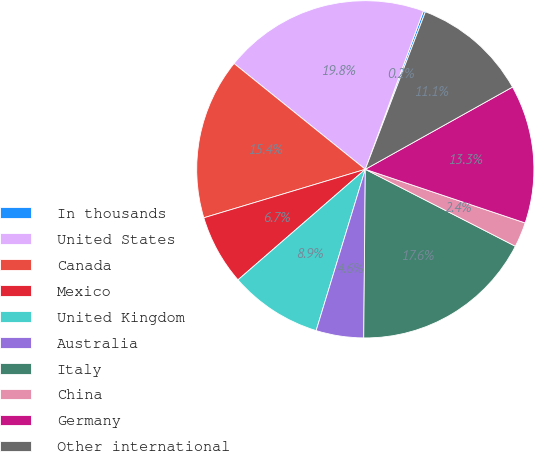Convert chart. <chart><loc_0><loc_0><loc_500><loc_500><pie_chart><fcel>In thousands<fcel>United States<fcel>Canada<fcel>Mexico<fcel>United Kingdom<fcel>Australia<fcel>Italy<fcel>China<fcel>Germany<fcel>Other international<nl><fcel>0.21%<fcel>19.79%<fcel>15.44%<fcel>6.74%<fcel>8.91%<fcel>4.56%<fcel>17.61%<fcel>2.39%<fcel>13.26%<fcel>11.09%<nl></chart> 